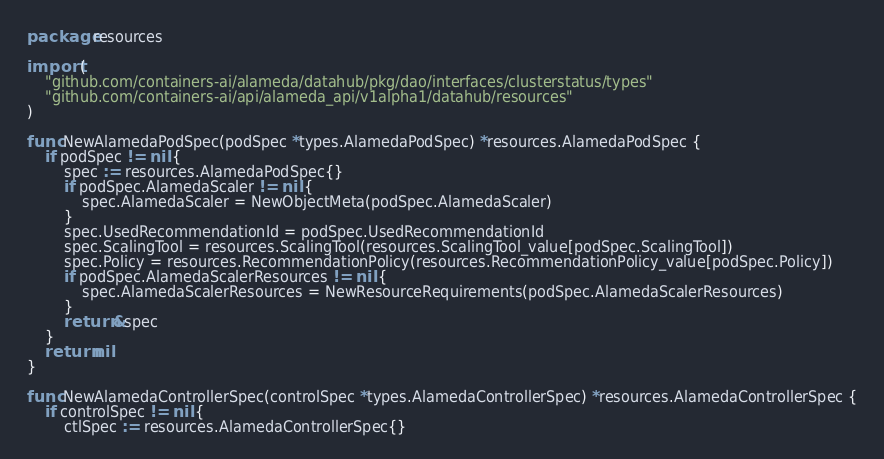<code> <loc_0><loc_0><loc_500><loc_500><_Go_>package resources

import (
	"github.com/containers-ai/alameda/datahub/pkg/dao/interfaces/clusterstatus/types"
	"github.com/containers-ai/api/alameda_api/v1alpha1/datahub/resources"
)

func NewAlamedaPodSpec(podSpec *types.AlamedaPodSpec) *resources.AlamedaPodSpec {
	if podSpec != nil {
		spec := resources.AlamedaPodSpec{}
		if podSpec.AlamedaScaler != nil {
			spec.AlamedaScaler = NewObjectMeta(podSpec.AlamedaScaler)
		}
		spec.UsedRecommendationId = podSpec.UsedRecommendationId
		spec.ScalingTool = resources.ScalingTool(resources.ScalingTool_value[podSpec.ScalingTool])
		spec.Policy = resources.RecommendationPolicy(resources.RecommendationPolicy_value[podSpec.Policy])
		if podSpec.AlamedaScalerResources != nil {
			spec.AlamedaScalerResources = NewResourceRequirements(podSpec.AlamedaScalerResources)
		}
		return &spec
	}
	return nil
}

func NewAlamedaControllerSpec(controlSpec *types.AlamedaControllerSpec) *resources.AlamedaControllerSpec {
	if controlSpec != nil {
		ctlSpec := resources.AlamedaControllerSpec{}</code> 